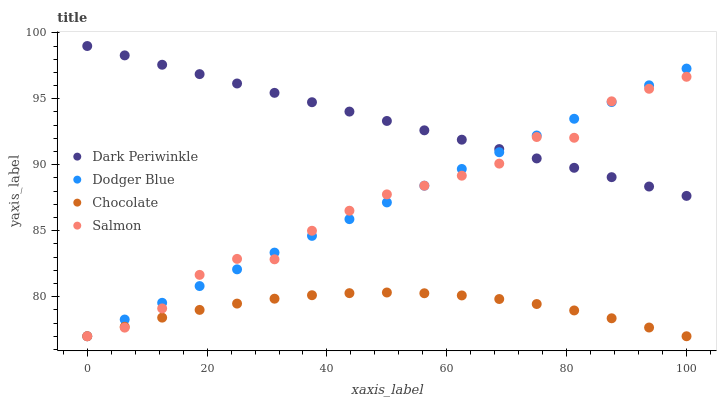Does Chocolate have the minimum area under the curve?
Answer yes or no. Yes. Does Dark Periwinkle have the maximum area under the curve?
Answer yes or no. Yes. Does Dodger Blue have the minimum area under the curve?
Answer yes or no. No. Does Dodger Blue have the maximum area under the curve?
Answer yes or no. No. Is Dodger Blue the smoothest?
Answer yes or no. Yes. Is Salmon the roughest?
Answer yes or no. Yes. Is Dark Periwinkle the smoothest?
Answer yes or no. No. Is Dark Periwinkle the roughest?
Answer yes or no. No. Does Salmon have the lowest value?
Answer yes or no. Yes. Does Dark Periwinkle have the lowest value?
Answer yes or no. No. Does Dark Periwinkle have the highest value?
Answer yes or no. Yes. Does Dodger Blue have the highest value?
Answer yes or no. No. Is Chocolate less than Dark Periwinkle?
Answer yes or no. Yes. Is Dark Periwinkle greater than Chocolate?
Answer yes or no. Yes. Does Dodger Blue intersect Chocolate?
Answer yes or no. Yes. Is Dodger Blue less than Chocolate?
Answer yes or no. No. Is Dodger Blue greater than Chocolate?
Answer yes or no. No. Does Chocolate intersect Dark Periwinkle?
Answer yes or no. No. 